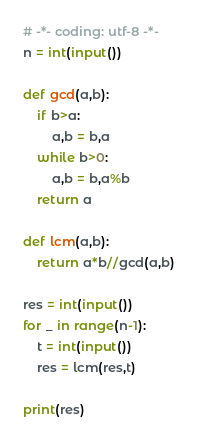<code> <loc_0><loc_0><loc_500><loc_500><_Python_># -*- coding: utf-8 -*-
n = int(input())

def gcd(a,b):
    if b>a:
        a,b = b,a
    while b>0:
        a,b = b,a%b
    return a

def lcm(a,b):
    return a*b//gcd(a,b)

res = int(input())
for _ in range(n-1):
    t = int(input())
    res = lcm(res,t)

print(res)
</code> 